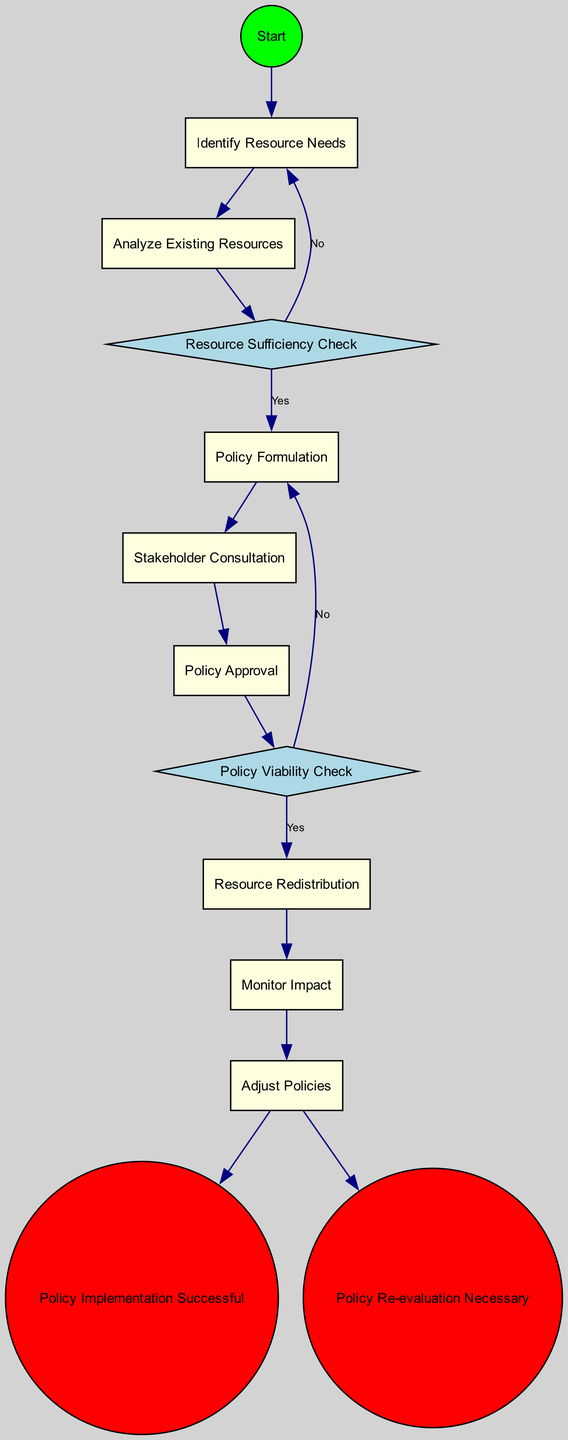What is the first activity listed in the diagram? The first activity listed is "Identify Resource Needs", which can be found connected directly to the start node in the flow of the diagram.
Answer: Identify Resource Needs How many decision points are present in the diagram? There are two decision points, "Resource Sufficiency Check" and "Policy Viability Check", shown in diamond-shaped nodes.
Answer: 2 What activity follows the "Analyze Existing Resources"? The activity that follows "Analyze Existing Resources" is "Policy Formulation", indicated by a direct edge leading from one node to the next in the diagram.
Answer: Policy Formulation If the "Resource Sufficiency Check" results in "No", which activity is revisited next? If "Resource Sufficiency Check" results in "No", the diagram indicates that it leads back to "Identify Resource Needs" for further assessment.
Answer: Identify Resource Needs What is the outcome if the "Policy Viability Check" indicates "No"? If the result of the "Policy Viability Check" is "No", the flow directs back to "Policy Formulation" for adjustments, as illustrated by the connecting edge indicating a return to that activity.
Answer: Policy Formulation What is the final outcome of the implementation process if successful? The final outcome of the implementation process, if successful, is labeled as "Policy Implementation Successful", which is represented in the diagram as an end point.
Answer: Policy Implementation Successful Which activity occurs just before the "Monitor Impact"? The activity that occurs just before "Monitor Impact" is "Resource Redistribution", connected directly in the sequence leading to the monitoring stage.
Answer: Resource Redistribution What shape are the stakeholder consultation activities represented by? The stakeholder consultation activities are represented by rectangular nodes in the diagram, indicating they are regular activities.
Answer: Rectangle What happens after the "Monitor Impact" activity? After "Monitor Impact", the next step allows for either the successful implementation condition or a need for policy re-evaluation based on the collected performance metrics.
Answer: Policy Implementation Successful or Policy Re-evaluation Necessary 